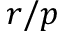Convert formula to latex. <formula><loc_0><loc_0><loc_500><loc_500>r / p</formula> 